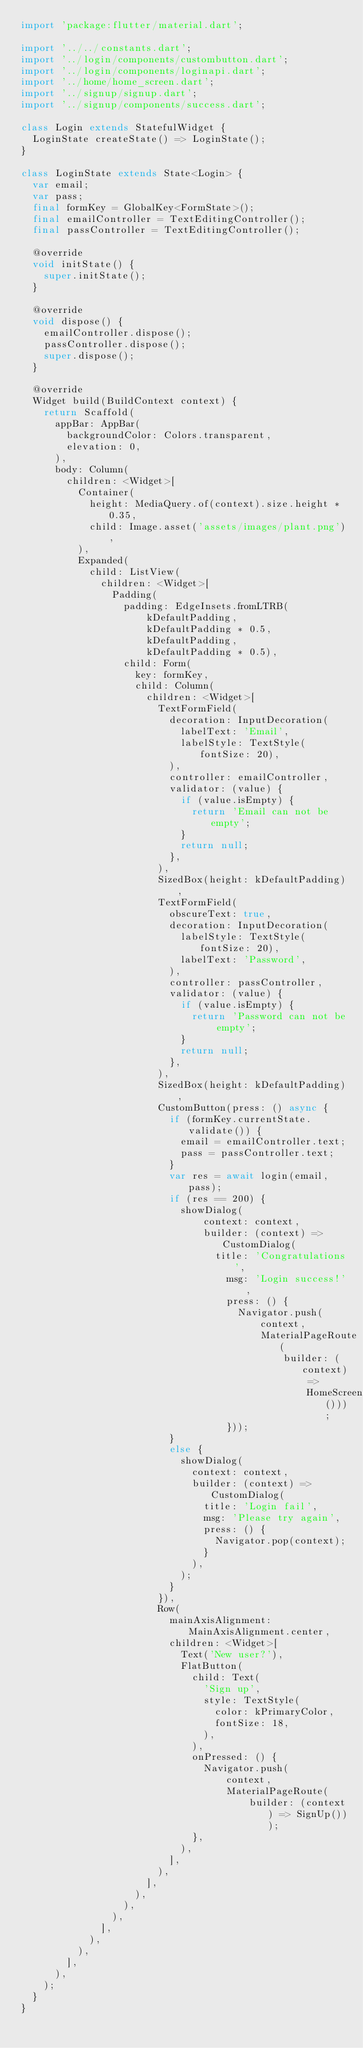<code> <loc_0><loc_0><loc_500><loc_500><_Dart_>import 'package:flutter/material.dart';

import '../../constants.dart';
import '../login/components/custombutton.dart';
import '../login/components/loginapi.dart';
import '../home/home_screen.dart';
import '../signup/signup.dart';
import '../signup/components/success.dart';

class Login extends StatefulWidget {
  LoginState createState() => LoginState();
}

class LoginState extends State<Login> {
  var email;
  var pass;
  final formKey = GlobalKey<FormState>();
  final emailController = TextEditingController();
  final passController = TextEditingController();

  @override
  void initState() {
    super.initState();
  }

  @override
  void dispose() {
    emailController.dispose();
    passController.dispose();
    super.dispose();
  }

  @override
  Widget build(BuildContext context) {
    return Scaffold(
      appBar: AppBar(
        backgroundColor: Colors.transparent,
        elevation: 0,
      ),
      body: Column(
        children: <Widget>[
          Container(
            height: MediaQuery.of(context).size.height * 0.35,
            child: Image.asset('assets/images/plant.png'),
          ),
          Expanded(
            child: ListView(
              children: <Widget>[
                Padding(
                  padding: EdgeInsets.fromLTRB(
                      kDefaultPadding,
                      kDefaultPadding * 0.5,
                      kDefaultPadding,
                      kDefaultPadding * 0.5),
                  child: Form(
                    key: formKey,
                    child: Column(
                      children: <Widget>[
                        TextFormField(
                          decoration: InputDecoration(
                            labelText: 'Email',
                            labelStyle: TextStyle(fontSize: 20),
                          ),
                          controller: emailController,
                          validator: (value) {
                            if (value.isEmpty) {
                              return 'Email can not be empty';
                            }
                            return null;
                          },
                        ),
                        SizedBox(height: kDefaultPadding),
                        TextFormField(
                          obscureText: true,
                          decoration: InputDecoration(
                            labelStyle: TextStyle(fontSize: 20),
                            labelText: 'Password',
                          ),
                          controller: passController,
                          validator: (value) {
                            if (value.isEmpty) {
                              return 'Password can not be empty';
                            }
                            return null;
                          },
                        ),
                        SizedBox(height: kDefaultPadding),
                        CustomButton(press: () async {
                          if (formKey.currentState.validate()) {
                            email = emailController.text;
                            pass = passController.text;
                          }
                          var res = await login(email, pass);
                          if (res == 200) {
                            showDialog(
                                context: context,
                                builder: (context) => CustomDialog(
                                  title: 'Congratulations',
                                    msg: 'Login success!',
                                    press: () {
                                      Navigator.push(
                                          context,
                                          MaterialPageRoute(
                                              builder: (context) =>
                                                  HomeScreen()));
                                    }));
                          }
                          else {
                            showDialog(
                              context: context,
                              builder: (context) => CustomDialog(
                                title: 'Login fail',
                                msg: 'Please try again',
                                press: () {
                                  Navigator.pop(context);
                                }
                              ),
                            );
                          }
                        }),
                        Row(
                          mainAxisAlignment: MainAxisAlignment.center,
                          children: <Widget>[
                            Text('New user?'),
                            FlatButton(
                              child: Text(
                                'Sign up',
                                style: TextStyle(
                                  color: kPrimaryColor,
                                  fontSize: 18,
                                ),
                              ),
                              onPressed: () {
                                Navigator.push(
                                    context,
                                    MaterialPageRoute(
                                        builder: (context) => SignUp()));
                              },
                            ),
                          ],
                        ),
                      ],
                    ),
                  ),
                ),
              ],
            ),
          ),
        ],
      ),
    );
  }
}
</code> 